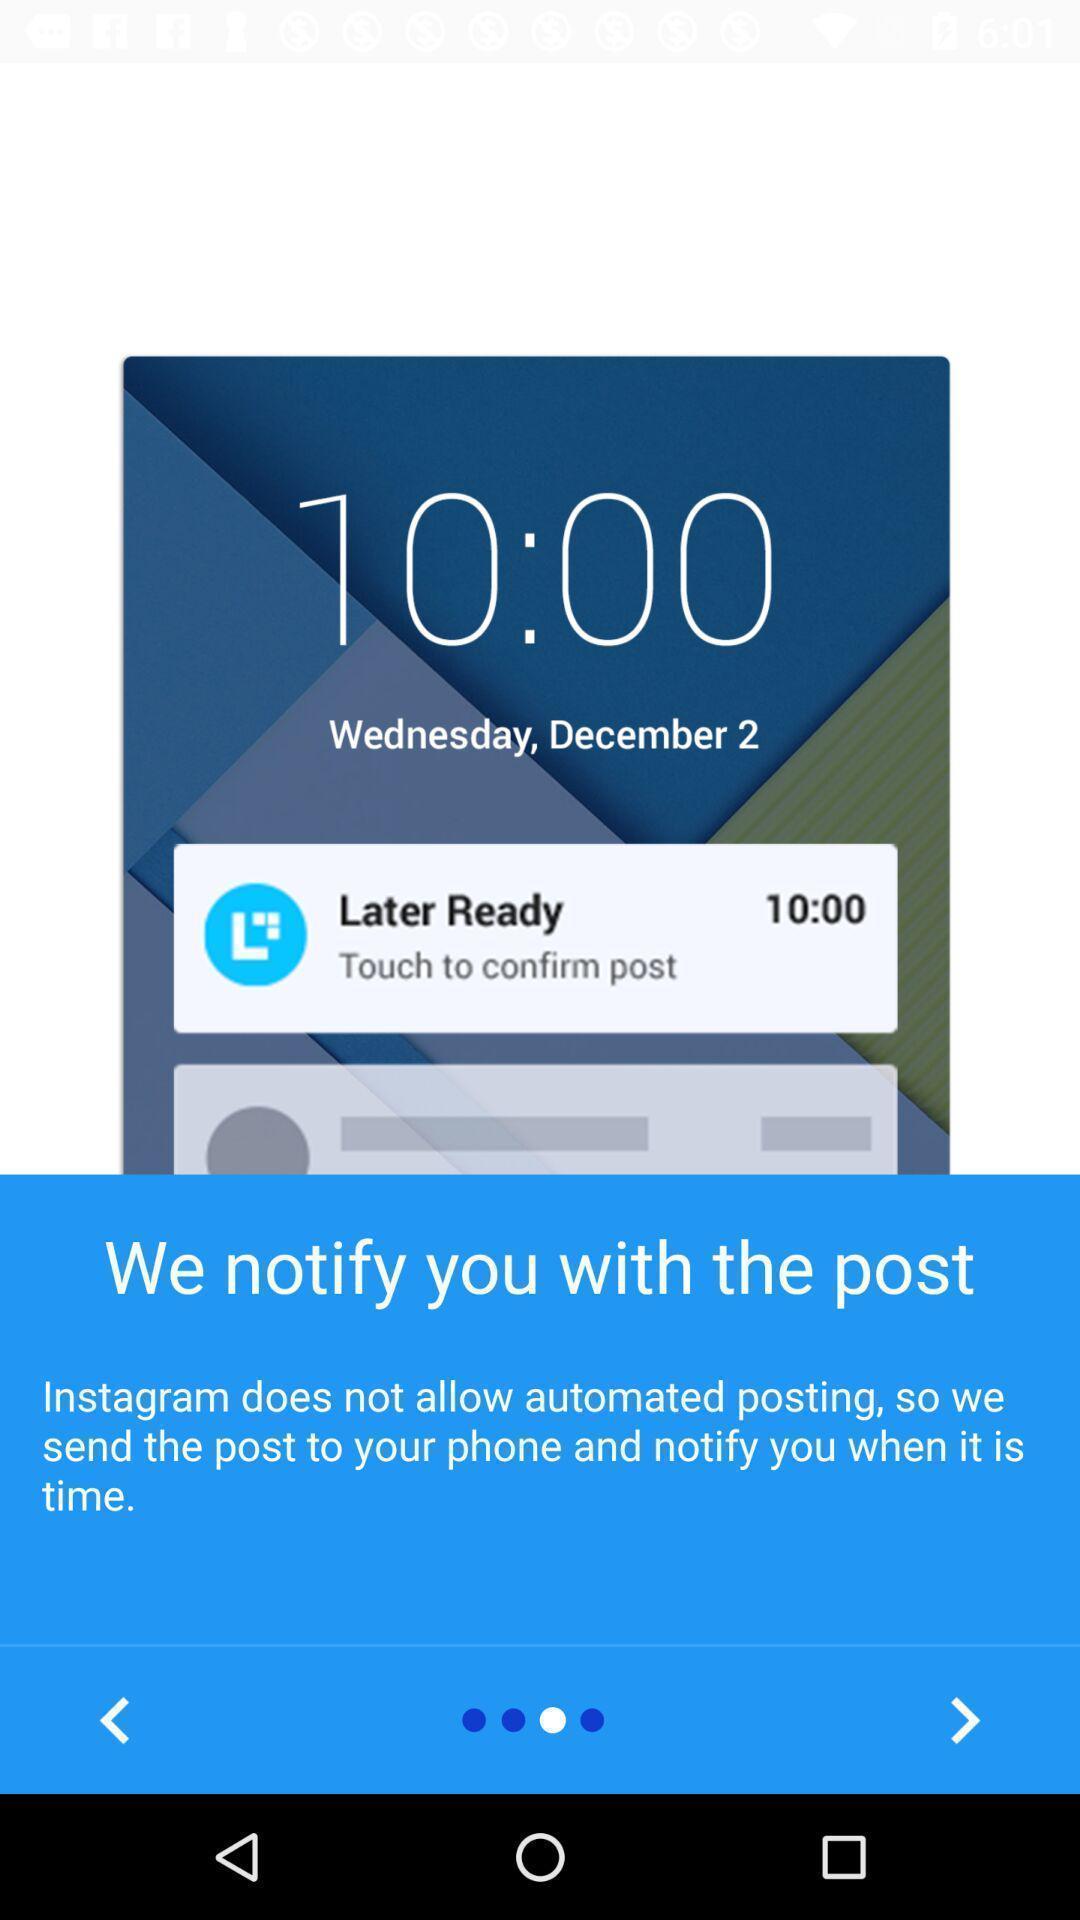Provide a description of this screenshot. Popup displaying notification information in a social application. 